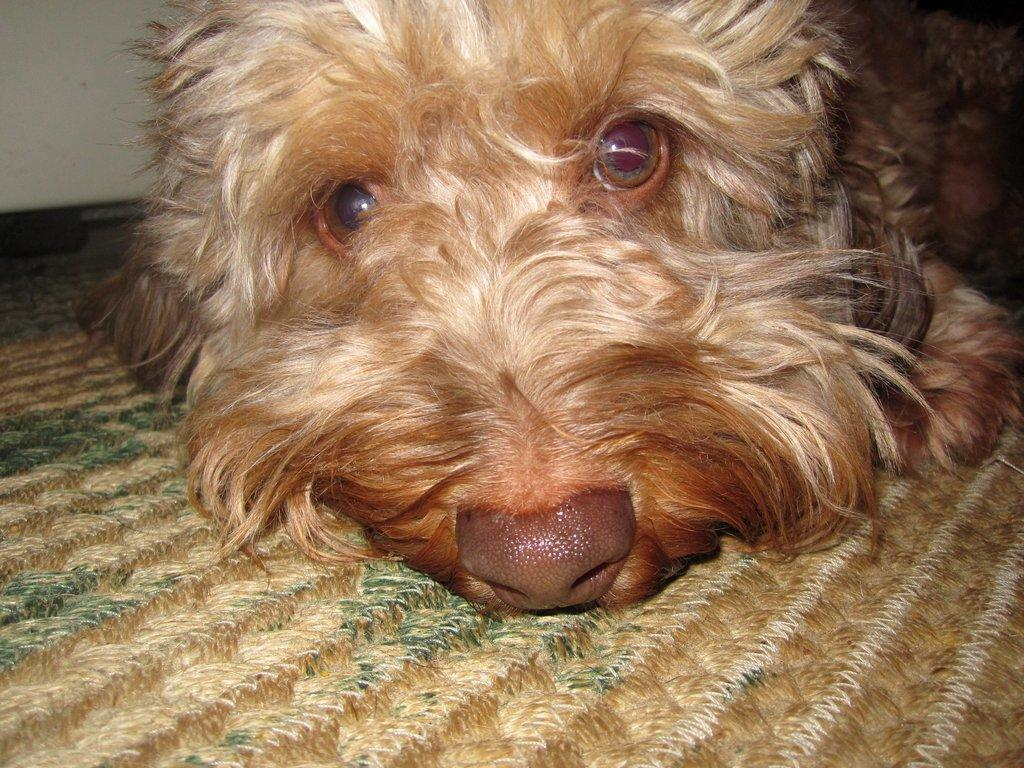What type of animal is present in the image? There is a dog in the image. What is located at the bottom of the image? There is a mat at the bottom of the image. Can you see the cook preparing a meal in the image? There is no cook or meal preparation visible in the image; it only features a dog and a mat. 